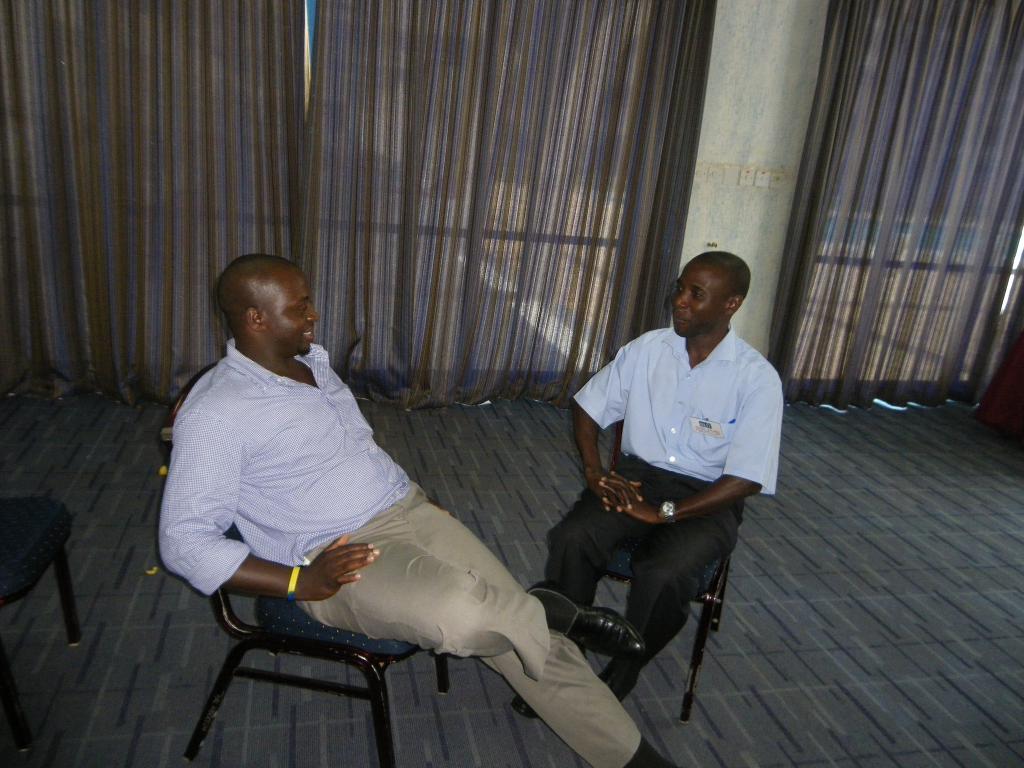Can you describe this image briefly? There are two persons sitting on chair. Person at the left side is wearing brown pant and shirt. There are curtains at the background of the image. At the left side there is a chair. Person at the right side is having a watch to his hand. 